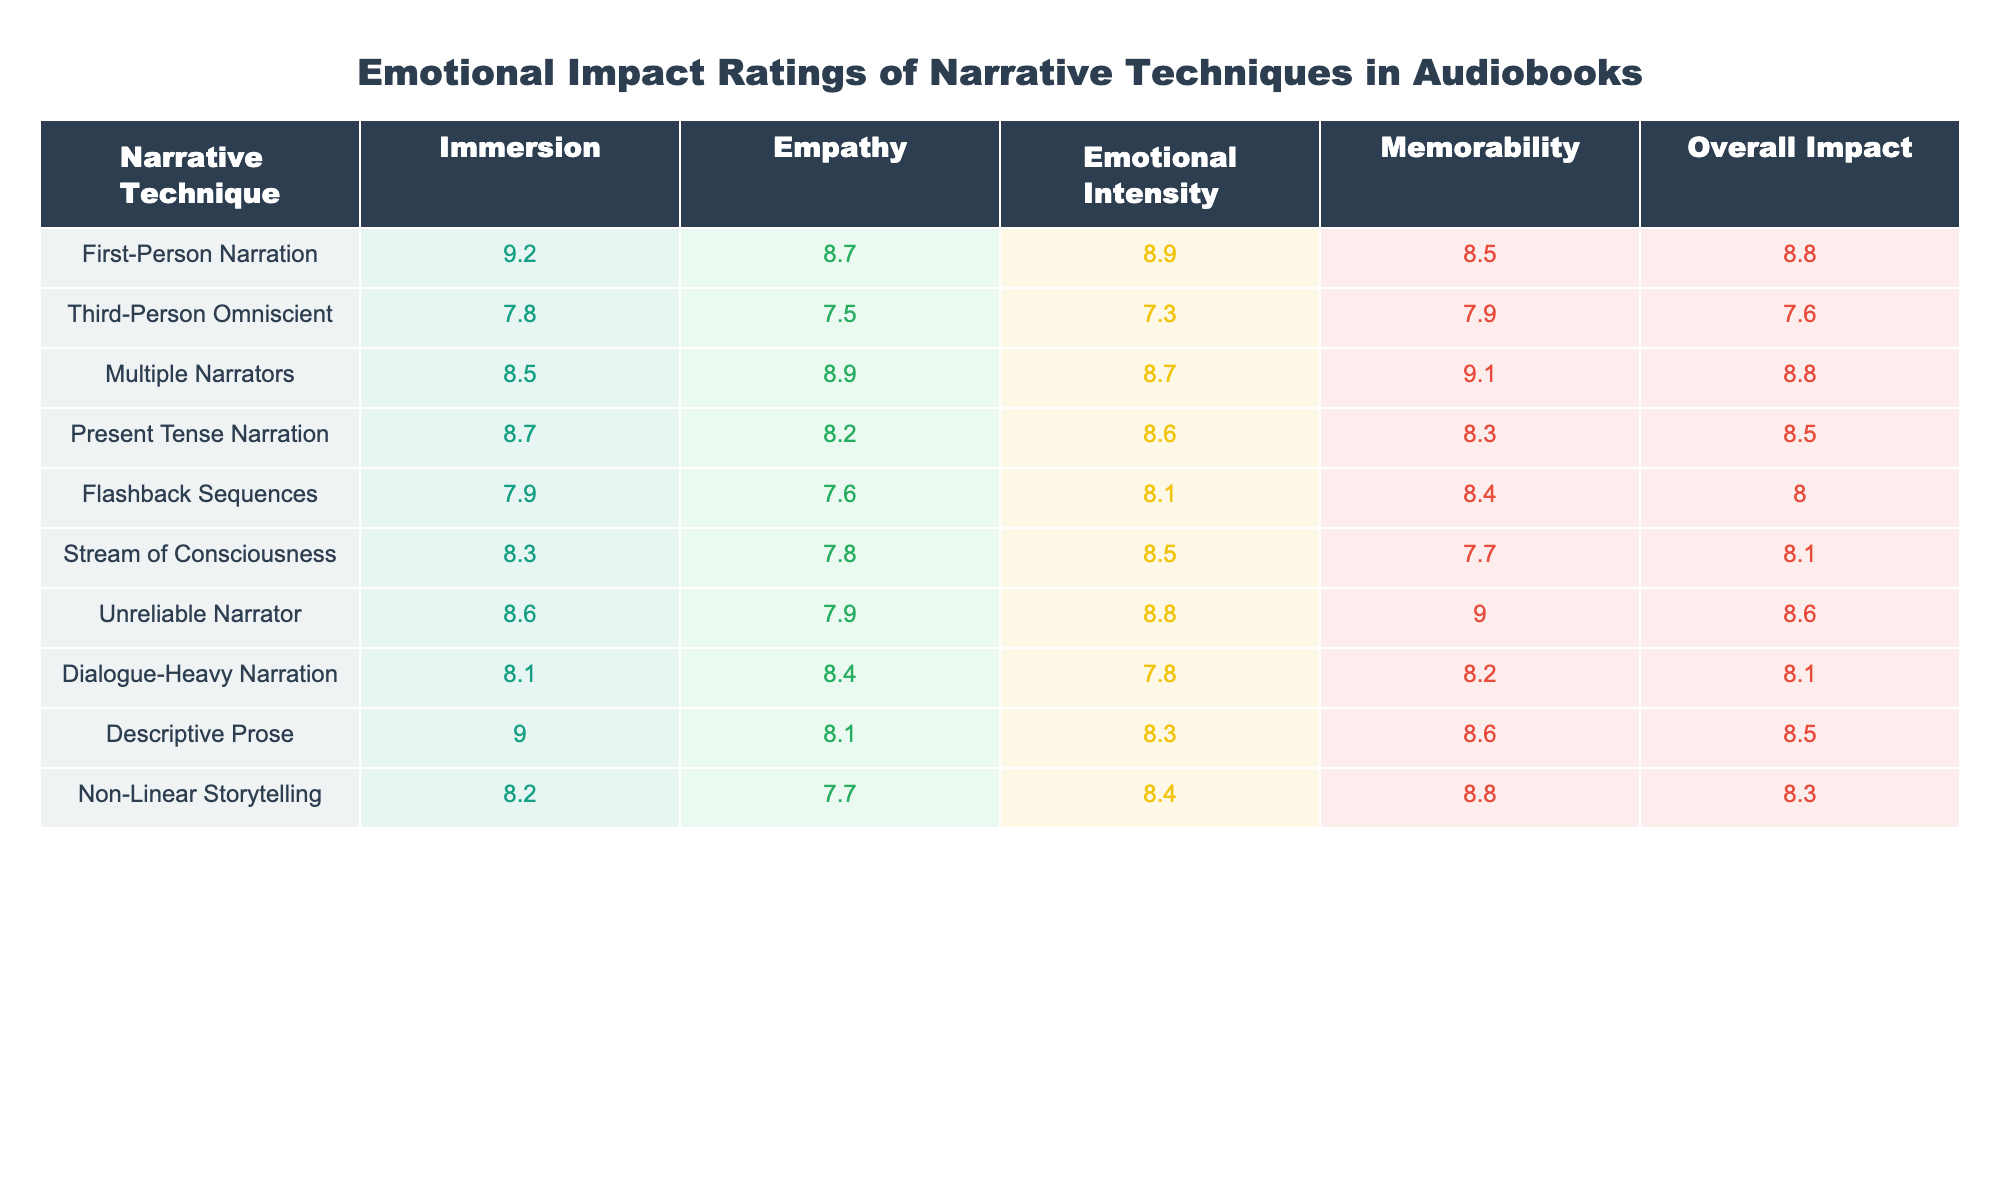What is the highest immersion rating among the narrative techniques? The immersion ratings are listed for each narrative technique. Among them, First-Person Narration has the highest score at 9.2.
Answer: 9.2 Which narrative technique has the lowest overall impact? By checking the overall impact ratings, Third-Person Omniscient scores the lowest at 7.6.
Answer: 7.6 What is the average empathy rating across all narrative techniques? To find the average empathy rating, sum the empathy values (8.7 + 7.5 + 8.9 + 8.2 + 7.6 + 7.8 + 7.9 + 8.4 + 8.1 + 7.7) = 86.8 and divide by the number of techniques (10), which gives 86.8 / 10 = 8.68.
Answer: 8.68 Is the emotional intensity rating for Multiple Narrators higher than that for Third-Person Omniscient? Multiple Narrators has an emotional intensity rating of 8.7, while Third-Person Omniscient has a rating of 7.3. Thus, 8.7 is indeed higher than 7.3.
Answer: Yes Which narrative technique has the highest memorability rating? Looking at the memorability ratings, Multiple Narrators has the highest value at 9.1.
Answer: 9.1 Calculate the difference in emotional intensity rating between Unreliable Narrator and Descriptive Prose. The emotional intensity rating for Unreliable Narrator is 8.8, and for Descriptive Prose, it's 8.3. The difference is 8.8 - 8.3 = 0.5.
Answer: 0.5 Which two narrative techniques have similar immersion ratings and what are those values? Looking at the immersion ratings, Present Tense Narration (8.7) and Multiple Narrators (8.5) are relatively close, with ratings that are near to each other, but Multiple Narrators has the lower value.
Answer: 8.7 and 8.5 Determine if Stream of Consciousness has a higher emotional intensity rating than Descriptive Prose. The emotional intensity for Stream of Consciousness is 8.5, whereas Descriptive Prose has a rating of 8.3. Therefore, 8.5 is greater than 8.3.
Answer: Yes Which narrative technique scores the same overall impact as Unreliable Narrator? Unreliable Narrator has an overall impact of 8.6. Checking others, Multiple Narrators also has an overall impact rating of 8.8, while no other technique matches Unreliable's rating.
Answer: No other technique matches 8.6 What is the median immersion rating of all the narrative techniques? The immersion ratings are: 9.2 (First-Person), 7.8 (Third-Person), 8.5 (Multiple), 8.7 (Present Tense), 7.9 (Flashback), 8.3 (Stream of Consciousness), 8.6 (Unreliable), 8.1 (Dialogue-Heavy), 9.0 (Descriptive), 8.2 (Non-Linear). Sorting these gives: 7.8, 7.9, 8.1, 8.2, 8.3, 8.5, 8.6, 8.7, 9.0, 9.2. The median is the average of the 5th and 6th values (8.3 and 8.5), which is 8.4.
Answer: 8.4 